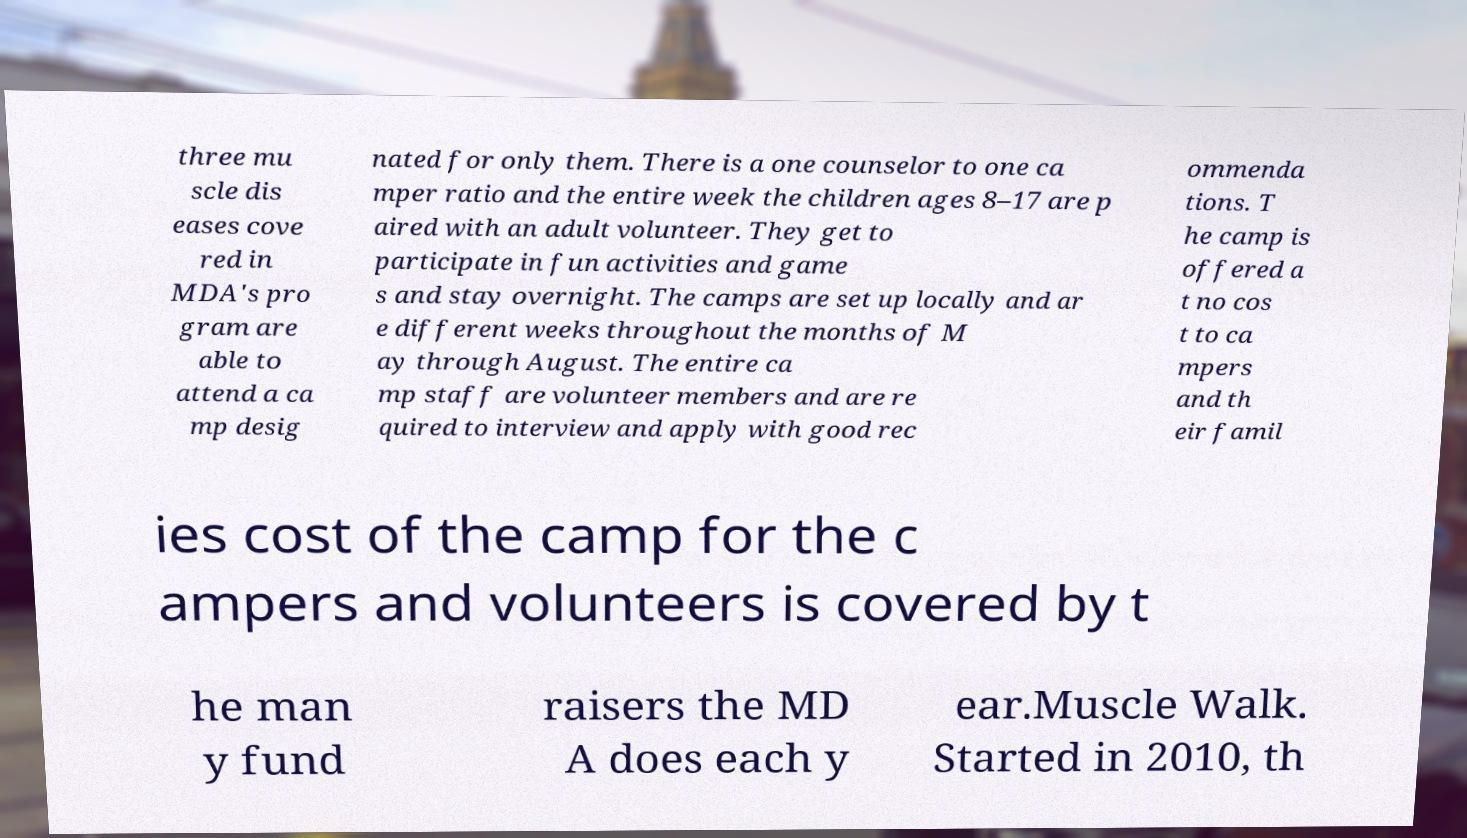For documentation purposes, I need the text within this image transcribed. Could you provide that? three mu scle dis eases cove red in MDA's pro gram are able to attend a ca mp desig nated for only them. There is a one counselor to one ca mper ratio and the entire week the children ages 8–17 are p aired with an adult volunteer. They get to participate in fun activities and game s and stay overnight. The camps are set up locally and ar e different weeks throughout the months of M ay through August. The entire ca mp staff are volunteer members and are re quired to interview and apply with good rec ommenda tions. T he camp is offered a t no cos t to ca mpers and th eir famil ies cost of the camp for the c ampers and volunteers is covered by t he man y fund raisers the MD A does each y ear.Muscle Walk. Started in 2010, th 